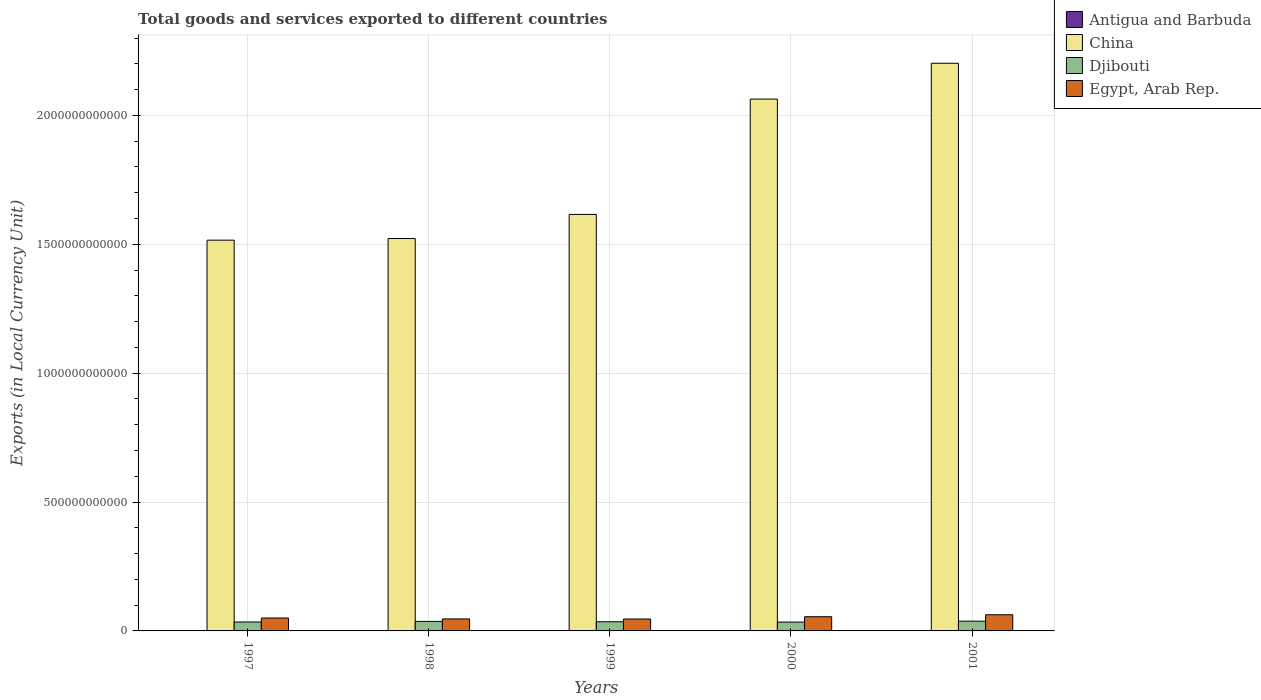Are the number of bars per tick equal to the number of legend labels?
Provide a short and direct response. Yes. How many bars are there on the 1st tick from the right?
Keep it short and to the point. 4. In how many cases, is the number of bars for a given year not equal to the number of legend labels?
Your answer should be compact. 0. What is the Amount of goods and services exports in China in 2000?
Ensure brevity in your answer.  2.06e+12. Across all years, what is the maximum Amount of goods and services exports in Egypt, Arab Rep.?
Give a very brief answer. 6.27e+1. Across all years, what is the minimum Amount of goods and services exports in China?
Make the answer very short. 1.52e+12. In which year was the Amount of goods and services exports in Djibouti maximum?
Provide a succinct answer. 2001. What is the total Amount of goods and services exports in Antigua and Barbuda in the graph?
Provide a short and direct response. 6.19e+09. What is the difference between the Amount of goods and services exports in Egypt, Arab Rep. in 1998 and that in 2001?
Make the answer very short. -1.61e+1. What is the difference between the Amount of goods and services exports in Antigua and Barbuda in 1998 and the Amount of goods and services exports in Djibouti in 1999?
Your response must be concise. -3.43e+1. What is the average Amount of goods and services exports in Egypt, Arab Rep. per year?
Offer a terse response. 5.22e+1. In the year 1997, what is the difference between the Amount of goods and services exports in China and Amount of goods and services exports in Antigua and Barbuda?
Provide a short and direct response. 1.51e+12. In how many years, is the Amount of goods and services exports in Djibouti greater than 1400000000000 LCU?
Make the answer very short. 0. What is the ratio of the Amount of goods and services exports in Antigua and Barbuda in 1998 to that in 2001?
Your answer should be very brief. 1.05. Is the Amount of goods and services exports in Djibouti in 1997 less than that in 2001?
Offer a very short reply. Yes. Is the difference between the Amount of goods and services exports in China in 1998 and 2000 greater than the difference between the Amount of goods and services exports in Antigua and Barbuda in 1998 and 2000?
Keep it short and to the point. No. What is the difference between the highest and the second highest Amount of goods and services exports in China?
Your response must be concise. 1.39e+11. What is the difference between the highest and the lowest Amount of goods and services exports in China?
Provide a succinct answer. 6.86e+11. What does the 2nd bar from the left in 2000 represents?
Keep it short and to the point. China. How many bars are there?
Your answer should be very brief. 20. Are all the bars in the graph horizontal?
Provide a short and direct response. No. What is the difference between two consecutive major ticks on the Y-axis?
Your response must be concise. 5.00e+11. Does the graph contain grids?
Provide a short and direct response. Yes. How many legend labels are there?
Ensure brevity in your answer.  4. How are the legend labels stacked?
Make the answer very short. Vertical. What is the title of the graph?
Keep it short and to the point. Total goods and services exported to different countries. What is the label or title of the X-axis?
Offer a very short reply. Years. What is the label or title of the Y-axis?
Offer a very short reply. Exports (in Local Currency Unit). What is the Exports (in Local Currency Unit) of Antigua and Barbuda in 1997?
Provide a short and direct response. 1.20e+09. What is the Exports (in Local Currency Unit) in China in 1997?
Provide a succinct answer. 1.52e+12. What is the Exports (in Local Currency Unit) of Djibouti in 1997?
Offer a very short reply. 3.47e+1. What is the Exports (in Local Currency Unit) in Egypt, Arab Rep. in 1997?
Your answer should be very brief. 5.01e+1. What is the Exports (in Local Currency Unit) of Antigua and Barbuda in 1998?
Provide a short and direct response. 1.26e+09. What is the Exports (in Local Currency Unit) of China in 1998?
Offer a terse response. 1.52e+12. What is the Exports (in Local Currency Unit) of Djibouti in 1998?
Ensure brevity in your answer.  3.70e+1. What is the Exports (in Local Currency Unit) in Egypt, Arab Rep. in 1998?
Provide a succinct answer. 4.66e+1. What is the Exports (in Local Currency Unit) in Antigua and Barbuda in 1999?
Provide a short and direct response. 1.28e+09. What is the Exports (in Local Currency Unit) of China in 1999?
Offer a terse response. 1.62e+12. What is the Exports (in Local Currency Unit) in Djibouti in 1999?
Keep it short and to the point. 3.56e+1. What is the Exports (in Local Currency Unit) of Egypt, Arab Rep. in 1999?
Offer a terse response. 4.63e+1. What is the Exports (in Local Currency Unit) of Antigua and Barbuda in 2000?
Ensure brevity in your answer.  1.26e+09. What is the Exports (in Local Currency Unit) in China in 2000?
Your answer should be compact. 2.06e+12. What is the Exports (in Local Currency Unit) in Djibouti in 2000?
Provide a succinct answer. 3.43e+1. What is the Exports (in Local Currency Unit) in Egypt, Arab Rep. in 2000?
Ensure brevity in your answer.  5.51e+1. What is the Exports (in Local Currency Unit) of Antigua and Barbuda in 2001?
Your answer should be compact. 1.20e+09. What is the Exports (in Local Currency Unit) of China in 2001?
Your response must be concise. 2.20e+12. What is the Exports (in Local Currency Unit) of Djibouti in 2001?
Offer a terse response. 3.79e+1. What is the Exports (in Local Currency Unit) of Egypt, Arab Rep. in 2001?
Provide a short and direct response. 6.27e+1. Across all years, what is the maximum Exports (in Local Currency Unit) of Antigua and Barbuda?
Offer a very short reply. 1.28e+09. Across all years, what is the maximum Exports (in Local Currency Unit) of China?
Your answer should be compact. 2.20e+12. Across all years, what is the maximum Exports (in Local Currency Unit) of Djibouti?
Your answer should be compact. 3.79e+1. Across all years, what is the maximum Exports (in Local Currency Unit) in Egypt, Arab Rep.?
Offer a terse response. 6.27e+1. Across all years, what is the minimum Exports (in Local Currency Unit) in Antigua and Barbuda?
Provide a succinct answer. 1.20e+09. Across all years, what is the minimum Exports (in Local Currency Unit) in China?
Your answer should be very brief. 1.52e+12. Across all years, what is the minimum Exports (in Local Currency Unit) of Djibouti?
Make the answer very short. 3.43e+1. Across all years, what is the minimum Exports (in Local Currency Unit) in Egypt, Arab Rep.?
Your answer should be very brief. 4.63e+1. What is the total Exports (in Local Currency Unit) of Antigua and Barbuda in the graph?
Give a very brief answer. 6.19e+09. What is the total Exports (in Local Currency Unit) in China in the graph?
Your response must be concise. 8.92e+12. What is the total Exports (in Local Currency Unit) in Djibouti in the graph?
Make the answer very short. 1.79e+11. What is the total Exports (in Local Currency Unit) in Egypt, Arab Rep. in the graph?
Your answer should be compact. 2.61e+11. What is the difference between the Exports (in Local Currency Unit) of Antigua and Barbuda in 1997 and that in 1998?
Ensure brevity in your answer.  -6.10e+07. What is the difference between the Exports (in Local Currency Unit) in China in 1997 and that in 1998?
Keep it short and to the point. -6.29e+09. What is the difference between the Exports (in Local Currency Unit) in Djibouti in 1997 and that in 1998?
Your answer should be compact. -2.28e+09. What is the difference between the Exports (in Local Currency Unit) of Egypt, Arab Rep. in 1997 and that in 1998?
Give a very brief answer. 3.50e+09. What is the difference between the Exports (in Local Currency Unit) in Antigua and Barbuda in 1997 and that in 1999?
Offer a terse response. -7.98e+07. What is the difference between the Exports (in Local Currency Unit) of China in 1997 and that in 1999?
Offer a very short reply. -9.99e+1. What is the difference between the Exports (in Local Currency Unit) in Djibouti in 1997 and that in 1999?
Ensure brevity in your answer.  -8.67e+08. What is the difference between the Exports (in Local Currency Unit) in Egypt, Arab Rep. in 1997 and that in 1999?
Keep it short and to the point. 3.80e+09. What is the difference between the Exports (in Local Currency Unit) of Antigua and Barbuda in 1997 and that in 2000?
Make the answer very short. -6.36e+07. What is the difference between the Exports (in Local Currency Unit) in China in 1997 and that in 2000?
Your answer should be very brief. -5.47e+11. What is the difference between the Exports (in Local Currency Unit) of Djibouti in 1997 and that in 2000?
Your answer should be very brief. 3.42e+08. What is the difference between the Exports (in Local Currency Unit) in Egypt, Arab Rep. in 1997 and that in 2000?
Offer a terse response. -5.00e+09. What is the difference between the Exports (in Local Currency Unit) in Antigua and Barbuda in 1997 and that in 2001?
Your answer should be very brief. -5.52e+06. What is the difference between the Exports (in Local Currency Unit) of China in 1997 and that in 2001?
Your answer should be very brief. -6.86e+11. What is the difference between the Exports (in Local Currency Unit) in Djibouti in 1997 and that in 2001?
Keep it short and to the point. -3.26e+09. What is the difference between the Exports (in Local Currency Unit) of Egypt, Arab Rep. in 1997 and that in 2001?
Your response must be concise. -1.26e+1. What is the difference between the Exports (in Local Currency Unit) of Antigua and Barbuda in 1998 and that in 1999?
Your answer should be compact. -1.87e+07. What is the difference between the Exports (in Local Currency Unit) in China in 1998 and that in 1999?
Your response must be concise. -9.36e+1. What is the difference between the Exports (in Local Currency Unit) of Djibouti in 1998 and that in 1999?
Ensure brevity in your answer.  1.41e+09. What is the difference between the Exports (in Local Currency Unit) in Egypt, Arab Rep. in 1998 and that in 1999?
Your response must be concise. 3.00e+08. What is the difference between the Exports (in Local Currency Unit) of Antigua and Barbuda in 1998 and that in 2000?
Offer a very short reply. -2.60e+06. What is the difference between the Exports (in Local Currency Unit) of China in 1998 and that in 2000?
Provide a succinct answer. -5.41e+11. What is the difference between the Exports (in Local Currency Unit) of Djibouti in 1998 and that in 2000?
Offer a very short reply. 2.62e+09. What is the difference between the Exports (in Local Currency Unit) of Egypt, Arab Rep. in 1998 and that in 2000?
Your response must be concise. -8.50e+09. What is the difference between the Exports (in Local Currency Unit) in Antigua and Barbuda in 1998 and that in 2001?
Provide a succinct answer. 5.55e+07. What is the difference between the Exports (in Local Currency Unit) in China in 1998 and that in 2001?
Your response must be concise. -6.80e+11. What is the difference between the Exports (in Local Currency Unit) in Djibouti in 1998 and that in 2001?
Ensure brevity in your answer.  -9.75e+08. What is the difference between the Exports (in Local Currency Unit) in Egypt, Arab Rep. in 1998 and that in 2001?
Your answer should be very brief. -1.61e+1. What is the difference between the Exports (in Local Currency Unit) of Antigua and Barbuda in 1999 and that in 2000?
Make the answer very short. 1.61e+07. What is the difference between the Exports (in Local Currency Unit) of China in 1999 and that in 2000?
Make the answer very short. -4.47e+11. What is the difference between the Exports (in Local Currency Unit) in Djibouti in 1999 and that in 2000?
Provide a succinct answer. 1.21e+09. What is the difference between the Exports (in Local Currency Unit) of Egypt, Arab Rep. in 1999 and that in 2000?
Your answer should be compact. -8.80e+09. What is the difference between the Exports (in Local Currency Unit) of Antigua and Barbuda in 1999 and that in 2001?
Keep it short and to the point. 7.42e+07. What is the difference between the Exports (in Local Currency Unit) in China in 1999 and that in 2001?
Offer a terse response. -5.86e+11. What is the difference between the Exports (in Local Currency Unit) in Djibouti in 1999 and that in 2001?
Offer a terse response. -2.39e+09. What is the difference between the Exports (in Local Currency Unit) of Egypt, Arab Rep. in 1999 and that in 2001?
Your answer should be very brief. -1.64e+1. What is the difference between the Exports (in Local Currency Unit) of Antigua and Barbuda in 2000 and that in 2001?
Provide a short and direct response. 5.81e+07. What is the difference between the Exports (in Local Currency Unit) in China in 2000 and that in 2001?
Offer a terse response. -1.39e+11. What is the difference between the Exports (in Local Currency Unit) in Djibouti in 2000 and that in 2001?
Offer a very short reply. -3.60e+09. What is the difference between the Exports (in Local Currency Unit) in Egypt, Arab Rep. in 2000 and that in 2001?
Your answer should be compact. -7.60e+09. What is the difference between the Exports (in Local Currency Unit) in Antigua and Barbuda in 1997 and the Exports (in Local Currency Unit) in China in 1998?
Provide a short and direct response. -1.52e+12. What is the difference between the Exports (in Local Currency Unit) in Antigua and Barbuda in 1997 and the Exports (in Local Currency Unit) in Djibouti in 1998?
Keep it short and to the point. -3.58e+1. What is the difference between the Exports (in Local Currency Unit) of Antigua and Barbuda in 1997 and the Exports (in Local Currency Unit) of Egypt, Arab Rep. in 1998?
Your answer should be very brief. -4.54e+1. What is the difference between the Exports (in Local Currency Unit) of China in 1997 and the Exports (in Local Currency Unit) of Djibouti in 1998?
Give a very brief answer. 1.48e+12. What is the difference between the Exports (in Local Currency Unit) in China in 1997 and the Exports (in Local Currency Unit) in Egypt, Arab Rep. in 1998?
Ensure brevity in your answer.  1.47e+12. What is the difference between the Exports (in Local Currency Unit) in Djibouti in 1997 and the Exports (in Local Currency Unit) in Egypt, Arab Rep. in 1998?
Provide a succinct answer. -1.19e+1. What is the difference between the Exports (in Local Currency Unit) in Antigua and Barbuda in 1997 and the Exports (in Local Currency Unit) in China in 1999?
Make the answer very short. -1.61e+12. What is the difference between the Exports (in Local Currency Unit) in Antigua and Barbuda in 1997 and the Exports (in Local Currency Unit) in Djibouti in 1999?
Ensure brevity in your answer.  -3.44e+1. What is the difference between the Exports (in Local Currency Unit) of Antigua and Barbuda in 1997 and the Exports (in Local Currency Unit) of Egypt, Arab Rep. in 1999?
Make the answer very short. -4.51e+1. What is the difference between the Exports (in Local Currency Unit) in China in 1997 and the Exports (in Local Currency Unit) in Djibouti in 1999?
Ensure brevity in your answer.  1.48e+12. What is the difference between the Exports (in Local Currency Unit) in China in 1997 and the Exports (in Local Currency Unit) in Egypt, Arab Rep. in 1999?
Your response must be concise. 1.47e+12. What is the difference between the Exports (in Local Currency Unit) of Djibouti in 1997 and the Exports (in Local Currency Unit) of Egypt, Arab Rep. in 1999?
Provide a succinct answer. -1.16e+1. What is the difference between the Exports (in Local Currency Unit) in Antigua and Barbuda in 1997 and the Exports (in Local Currency Unit) in China in 2000?
Your answer should be very brief. -2.06e+12. What is the difference between the Exports (in Local Currency Unit) in Antigua and Barbuda in 1997 and the Exports (in Local Currency Unit) in Djibouti in 2000?
Your answer should be compact. -3.31e+1. What is the difference between the Exports (in Local Currency Unit) of Antigua and Barbuda in 1997 and the Exports (in Local Currency Unit) of Egypt, Arab Rep. in 2000?
Make the answer very short. -5.39e+1. What is the difference between the Exports (in Local Currency Unit) in China in 1997 and the Exports (in Local Currency Unit) in Djibouti in 2000?
Offer a very short reply. 1.48e+12. What is the difference between the Exports (in Local Currency Unit) in China in 1997 and the Exports (in Local Currency Unit) in Egypt, Arab Rep. in 2000?
Keep it short and to the point. 1.46e+12. What is the difference between the Exports (in Local Currency Unit) of Djibouti in 1997 and the Exports (in Local Currency Unit) of Egypt, Arab Rep. in 2000?
Your response must be concise. -2.04e+1. What is the difference between the Exports (in Local Currency Unit) in Antigua and Barbuda in 1997 and the Exports (in Local Currency Unit) in China in 2001?
Ensure brevity in your answer.  -2.20e+12. What is the difference between the Exports (in Local Currency Unit) in Antigua and Barbuda in 1997 and the Exports (in Local Currency Unit) in Djibouti in 2001?
Provide a succinct answer. -3.67e+1. What is the difference between the Exports (in Local Currency Unit) in Antigua and Barbuda in 1997 and the Exports (in Local Currency Unit) in Egypt, Arab Rep. in 2001?
Your answer should be compact. -6.15e+1. What is the difference between the Exports (in Local Currency Unit) of China in 1997 and the Exports (in Local Currency Unit) of Djibouti in 2001?
Provide a succinct answer. 1.48e+12. What is the difference between the Exports (in Local Currency Unit) in China in 1997 and the Exports (in Local Currency Unit) in Egypt, Arab Rep. in 2001?
Give a very brief answer. 1.45e+12. What is the difference between the Exports (in Local Currency Unit) in Djibouti in 1997 and the Exports (in Local Currency Unit) in Egypt, Arab Rep. in 2001?
Give a very brief answer. -2.80e+1. What is the difference between the Exports (in Local Currency Unit) in Antigua and Barbuda in 1998 and the Exports (in Local Currency Unit) in China in 1999?
Offer a terse response. -1.61e+12. What is the difference between the Exports (in Local Currency Unit) in Antigua and Barbuda in 1998 and the Exports (in Local Currency Unit) in Djibouti in 1999?
Offer a terse response. -3.43e+1. What is the difference between the Exports (in Local Currency Unit) of Antigua and Barbuda in 1998 and the Exports (in Local Currency Unit) of Egypt, Arab Rep. in 1999?
Ensure brevity in your answer.  -4.50e+1. What is the difference between the Exports (in Local Currency Unit) in China in 1998 and the Exports (in Local Currency Unit) in Djibouti in 1999?
Keep it short and to the point. 1.49e+12. What is the difference between the Exports (in Local Currency Unit) in China in 1998 and the Exports (in Local Currency Unit) in Egypt, Arab Rep. in 1999?
Your response must be concise. 1.48e+12. What is the difference between the Exports (in Local Currency Unit) in Djibouti in 1998 and the Exports (in Local Currency Unit) in Egypt, Arab Rep. in 1999?
Your answer should be compact. -9.33e+09. What is the difference between the Exports (in Local Currency Unit) of Antigua and Barbuda in 1998 and the Exports (in Local Currency Unit) of China in 2000?
Provide a short and direct response. -2.06e+12. What is the difference between the Exports (in Local Currency Unit) of Antigua and Barbuda in 1998 and the Exports (in Local Currency Unit) of Djibouti in 2000?
Offer a terse response. -3.31e+1. What is the difference between the Exports (in Local Currency Unit) of Antigua and Barbuda in 1998 and the Exports (in Local Currency Unit) of Egypt, Arab Rep. in 2000?
Keep it short and to the point. -5.38e+1. What is the difference between the Exports (in Local Currency Unit) in China in 1998 and the Exports (in Local Currency Unit) in Djibouti in 2000?
Make the answer very short. 1.49e+12. What is the difference between the Exports (in Local Currency Unit) in China in 1998 and the Exports (in Local Currency Unit) in Egypt, Arab Rep. in 2000?
Your answer should be compact. 1.47e+12. What is the difference between the Exports (in Local Currency Unit) in Djibouti in 1998 and the Exports (in Local Currency Unit) in Egypt, Arab Rep. in 2000?
Give a very brief answer. -1.81e+1. What is the difference between the Exports (in Local Currency Unit) of Antigua and Barbuda in 1998 and the Exports (in Local Currency Unit) of China in 2001?
Offer a terse response. -2.20e+12. What is the difference between the Exports (in Local Currency Unit) of Antigua and Barbuda in 1998 and the Exports (in Local Currency Unit) of Djibouti in 2001?
Make the answer very short. -3.67e+1. What is the difference between the Exports (in Local Currency Unit) in Antigua and Barbuda in 1998 and the Exports (in Local Currency Unit) in Egypt, Arab Rep. in 2001?
Make the answer very short. -6.14e+1. What is the difference between the Exports (in Local Currency Unit) in China in 1998 and the Exports (in Local Currency Unit) in Djibouti in 2001?
Your response must be concise. 1.48e+12. What is the difference between the Exports (in Local Currency Unit) in China in 1998 and the Exports (in Local Currency Unit) in Egypt, Arab Rep. in 2001?
Keep it short and to the point. 1.46e+12. What is the difference between the Exports (in Local Currency Unit) of Djibouti in 1998 and the Exports (in Local Currency Unit) of Egypt, Arab Rep. in 2001?
Give a very brief answer. -2.57e+1. What is the difference between the Exports (in Local Currency Unit) in Antigua and Barbuda in 1999 and the Exports (in Local Currency Unit) in China in 2000?
Make the answer very short. -2.06e+12. What is the difference between the Exports (in Local Currency Unit) of Antigua and Barbuda in 1999 and the Exports (in Local Currency Unit) of Djibouti in 2000?
Your response must be concise. -3.31e+1. What is the difference between the Exports (in Local Currency Unit) in Antigua and Barbuda in 1999 and the Exports (in Local Currency Unit) in Egypt, Arab Rep. in 2000?
Keep it short and to the point. -5.38e+1. What is the difference between the Exports (in Local Currency Unit) in China in 1999 and the Exports (in Local Currency Unit) in Djibouti in 2000?
Make the answer very short. 1.58e+12. What is the difference between the Exports (in Local Currency Unit) in China in 1999 and the Exports (in Local Currency Unit) in Egypt, Arab Rep. in 2000?
Your answer should be very brief. 1.56e+12. What is the difference between the Exports (in Local Currency Unit) of Djibouti in 1999 and the Exports (in Local Currency Unit) of Egypt, Arab Rep. in 2000?
Ensure brevity in your answer.  -1.95e+1. What is the difference between the Exports (in Local Currency Unit) in Antigua and Barbuda in 1999 and the Exports (in Local Currency Unit) in China in 2001?
Offer a very short reply. -2.20e+12. What is the difference between the Exports (in Local Currency Unit) in Antigua and Barbuda in 1999 and the Exports (in Local Currency Unit) in Djibouti in 2001?
Provide a succinct answer. -3.67e+1. What is the difference between the Exports (in Local Currency Unit) in Antigua and Barbuda in 1999 and the Exports (in Local Currency Unit) in Egypt, Arab Rep. in 2001?
Give a very brief answer. -6.14e+1. What is the difference between the Exports (in Local Currency Unit) of China in 1999 and the Exports (in Local Currency Unit) of Djibouti in 2001?
Offer a terse response. 1.58e+12. What is the difference between the Exports (in Local Currency Unit) in China in 1999 and the Exports (in Local Currency Unit) in Egypt, Arab Rep. in 2001?
Give a very brief answer. 1.55e+12. What is the difference between the Exports (in Local Currency Unit) of Djibouti in 1999 and the Exports (in Local Currency Unit) of Egypt, Arab Rep. in 2001?
Keep it short and to the point. -2.71e+1. What is the difference between the Exports (in Local Currency Unit) in Antigua and Barbuda in 2000 and the Exports (in Local Currency Unit) in China in 2001?
Make the answer very short. -2.20e+12. What is the difference between the Exports (in Local Currency Unit) of Antigua and Barbuda in 2000 and the Exports (in Local Currency Unit) of Djibouti in 2001?
Offer a terse response. -3.67e+1. What is the difference between the Exports (in Local Currency Unit) of Antigua and Barbuda in 2000 and the Exports (in Local Currency Unit) of Egypt, Arab Rep. in 2001?
Ensure brevity in your answer.  -6.14e+1. What is the difference between the Exports (in Local Currency Unit) of China in 2000 and the Exports (in Local Currency Unit) of Djibouti in 2001?
Give a very brief answer. 2.03e+12. What is the difference between the Exports (in Local Currency Unit) of China in 2000 and the Exports (in Local Currency Unit) of Egypt, Arab Rep. in 2001?
Provide a succinct answer. 2.00e+12. What is the difference between the Exports (in Local Currency Unit) of Djibouti in 2000 and the Exports (in Local Currency Unit) of Egypt, Arab Rep. in 2001?
Your answer should be very brief. -2.84e+1. What is the average Exports (in Local Currency Unit) in Antigua and Barbuda per year?
Your answer should be very brief. 1.24e+09. What is the average Exports (in Local Currency Unit) of China per year?
Offer a terse response. 1.78e+12. What is the average Exports (in Local Currency Unit) of Djibouti per year?
Your answer should be compact. 3.59e+1. What is the average Exports (in Local Currency Unit) in Egypt, Arab Rep. per year?
Ensure brevity in your answer.  5.22e+1. In the year 1997, what is the difference between the Exports (in Local Currency Unit) of Antigua and Barbuda and Exports (in Local Currency Unit) of China?
Ensure brevity in your answer.  -1.51e+12. In the year 1997, what is the difference between the Exports (in Local Currency Unit) in Antigua and Barbuda and Exports (in Local Currency Unit) in Djibouti?
Provide a short and direct response. -3.35e+1. In the year 1997, what is the difference between the Exports (in Local Currency Unit) of Antigua and Barbuda and Exports (in Local Currency Unit) of Egypt, Arab Rep.?
Offer a very short reply. -4.89e+1. In the year 1997, what is the difference between the Exports (in Local Currency Unit) in China and Exports (in Local Currency Unit) in Djibouti?
Offer a very short reply. 1.48e+12. In the year 1997, what is the difference between the Exports (in Local Currency Unit) in China and Exports (in Local Currency Unit) in Egypt, Arab Rep.?
Provide a succinct answer. 1.47e+12. In the year 1997, what is the difference between the Exports (in Local Currency Unit) of Djibouti and Exports (in Local Currency Unit) of Egypt, Arab Rep.?
Ensure brevity in your answer.  -1.54e+1. In the year 1998, what is the difference between the Exports (in Local Currency Unit) of Antigua and Barbuda and Exports (in Local Currency Unit) of China?
Your response must be concise. -1.52e+12. In the year 1998, what is the difference between the Exports (in Local Currency Unit) in Antigua and Barbuda and Exports (in Local Currency Unit) in Djibouti?
Give a very brief answer. -3.57e+1. In the year 1998, what is the difference between the Exports (in Local Currency Unit) of Antigua and Barbuda and Exports (in Local Currency Unit) of Egypt, Arab Rep.?
Ensure brevity in your answer.  -4.53e+1. In the year 1998, what is the difference between the Exports (in Local Currency Unit) in China and Exports (in Local Currency Unit) in Djibouti?
Provide a short and direct response. 1.49e+12. In the year 1998, what is the difference between the Exports (in Local Currency Unit) of China and Exports (in Local Currency Unit) of Egypt, Arab Rep.?
Your response must be concise. 1.48e+12. In the year 1998, what is the difference between the Exports (in Local Currency Unit) of Djibouti and Exports (in Local Currency Unit) of Egypt, Arab Rep.?
Provide a short and direct response. -9.63e+09. In the year 1999, what is the difference between the Exports (in Local Currency Unit) in Antigua and Barbuda and Exports (in Local Currency Unit) in China?
Offer a very short reply. -1.61e+12. In the year 1999, what is the difference between the Exports (in Local Currency Unit) in Antigua and Barbuda and Exports (in Local Currency Unit) in Djibouti?
Your answer should be compact. -3.43e+1. In the year 1999, what is the difference between the Exports (in Local Currency Unit) in Antigua and Barbuda and Exports (in Local Currency Unit) in Egypt, Arab Rep.?
Your answer should be compact. -4.50e+1. In the year 1999, what is the difference between the Exports (in Local Currency Unit) of China and Exports (in Local Currency Unit) of Djibouti?
Offer a terse response. 1.58e+12. In the year 1999, what is the difference between the Exports (in Local Currency Unit) of China and Exports (in Local Currency Unit) of Egypt, Arab Rep.?
Keep it short and to the point. 1.57e+12. In the year 1999, what is the difference between the Exports (in Local Currency Unit) in Djibouti and Exports (in Local Currency Unit) in Egypt, Arab Rep.?
Give a very brief answer. -1.07e+1. In the year 2000, what is the difference between the Exports (in Local Currency Unit) in Antigua and Barbuda and Exports (in Local Currency Unit) in China?
Provide a short and direct response. -2.06e+12. In the year 2000, what is the difference between the Exports (in Local Currency Unit) of Antigua and Barbuda and Exports (in Local Currency Unit) of Djibouti?
Offer a very short reply. -3.31e+1. In the year 2000, what is the difference between the Exports (in Local Currency Unit) of Antigua and Barbuda and Exports (in Local Currency Unit) of Egypt, Arab Rep.?
Ensure brevity in your answer.  -5.38e+1. In the year 2000, what is the difference between the Exports (in Local Currency Unit) in China and Exports (in Local Currency Unit) in Djibouti?
Make the answer very short. 2.03e+12. In the year 2000, what is the difference between the Exports (in Local Currency Unit) of China and Exports (in Local Currency Unit) of Egypt, Arab Rep.?
Your response must be concise. 2.01e+12. In the year 2000, what is the difference between the Exports (in Local Currency Unit) in Djibouti and Exports (in Local Currency Unit) in Egypt, Arab Rep.?
Your response must be concise. -2.08e+1. In the year 2001, what is the difference between the Exports (in Local Currency Unit) in Antigua and Barbuda and Exports (in Local Currency Unit) in China?
Offer a terse response. -2.20e+12. In the year 2001, what is the difference between the Exports (in Local Currency Unit) in Antigua and Barbuda and Exports (in Local Currency Unit) in Djibouti?
Give a very brief answer. -3.67e+1. In the year 2001, what is the difference between the Exports (in Local Currency Unit) in Antigua and Barbuda and Exports (in Local Currency Unit) in Egypt, Arab Rep.?
Provide a short and direct response. -6.15e+1. In the year 2001, what is the difference between the Exports (in Local Currency Unit) in China and Exports (in Local Currency Unit) in Djibouti?
Ensure brevity in your answer.  2.16e+12. In the year 2001, what is the difference between the Exports (in Local Currency Unit) in China and Exports (in Local Currency Unit) in Egypt, Arab Rep.?
Give a very brief answer. 2.14e+12. In the year 2001, what is the difference between the Exports (in Local Currency Unit) of Djibouti and Exports (in Local Currency Unit) of Egypt, Arab Rep.?
Offer a very short reply. -2.48e+1. What is the ratio of the Exports (in Local Currency Unit) of Antigua and Barbuda in 1997 to that in 1998?
Provide a succinct answer. 0.95. What is the ratio of the Exports (in Local Currency Unit) in China in 1997 to that in 1998?
Provide a short and direct response. 1. What is the ratio of the Exports (in Local Currency Unit) of Djibouti in 1997 to that in 1998?
Your answer should be compact. 0.94. What is the ratio of the Exports (in Local Currency Unit) of Egypt, Arab Rep. in 1997 to that in 1998?
Your answer should be compact. 1.08. What is the ratio of the Exports (in Local Currency Unit) in Antigua and Barbuda in 1997 to that in 1999?
Make the answer very short. 0.94. What is the ratio of the Exports (in Local Currency Unit) of China in 1997 to that in 1999?
Provide a succinct answer. 0.94. What is the ratio of the Exports (in Local Currency Unit) in Djibouti in 1997 to that in 1999?
Your answer should be very brief. 0.98. What is the ratio of the Exports (in Local Currency Unit) in Egypt, Arab Rep. in 1997 to that in 1999?
Give a very brief answer. 1.08. What is the ratio of the Exports (in Local Currency Unit) of Antigua and Barbuda in 1997 to that in 2000?
Make the answer very short. 0.95. What is the ratio of the Exports (in Local Currency Unit) in China in 1997 to that in 2000?
Your answer should be very brief. 0.73. What is the ratio of the Exports (in Local Currency Unit) in Djibouti in 1997 to that in 2000?
Provide a short and direct response. 1.01. What is the ratio of the Exports (in Local Currency Unit) of Egypt, Arab Rep. in 1997 to that in 2000?
Provide a short and direct response. 0.91. What is the ratio of the Exports (in Local Currency Unit) in China in 1997 to that in 2001?
Offer a very short reply. 0.69. What is the ratio of the Exports (in Local Currency Unit) in Djibouti in 1997 to that in 2001?
Provide a short and direct response. 0.91. What is the ratio of the Exports (in Local Currency Unit) in Egypt, Arab Rep. in 1997 to that in 2001?
Provide a succinct answer. 0.8. What is the ratio of the Exports (in Local Currency Unit) in Antigua and Barbuda in 1998 to that in 1999?
Keep it short and to the point. 0.99. What is the ratio of the Exports (in Local Currency Unit) of China in 1998 to that in 1999?
Provide a succinct answer. 0.94. What is the ratio of the Exports (in Local Currency Unit) in Djibouti in 1998 to that in 1999?
Your answer should be compact. 1.04. What is the ratio of the Exports (in Local Currency Unit) of China in 1998 to that in 2000?
Your response must be concise. 0.74. What is the ratio of the Exports (in Local Currency Unit) of Djibouti in 1998 to that in 2000?
Offer a very short reply. 1.08. What is the ratio of the Exports (in Local Currency Unit) of Egypt, Arab Rep. in 1998 to that in 2000?
Offer a very short reply. 0.85. What is the ratio of the Exports (in Local Currency Unit) in Antigua and Barbuda in 1998 to that in 2001?
Keep it short and to the point. 1.05. What is the ratio of the Exports (in Local Currency Unit) in China in 1998 to that in 2001?
Ensure brevity in your answer.  0.69. What is the ratio of the Exports (in Local Currency Unit) in Djibouti in 1998 to that in 2001?
Offer a very short reply. 0.97. What is the ratio of the Exports (in Local Currency Unit) in Egypt, Arab Rep. in 1998 to that in 2001?
Offer a very short reply. 0.74. What is the ratio of the Exports (in Local Currency Unit) of Antigua and Barbuda in 1999 to that in 2000?
Make the answer very short. 1.01. What is the ratio of the Exports (in Local Currency Unit) of China in 1999 to that in 2000?
Your response must be concise. 0.78. What is the ratio of the Exports (in Local Currency Unit) of Djibouti in 1999 to that in 2000?
Your answer should be compact. 1.04. What is the ratio of the Exports (in Local Currency Unit) of Egypt, Arab Rep. in 1999 to that in 2000?
Your response must be concise. 0.84. What is the ratio of the Exports (in Local Currency Unit) in Antigua and Barbuda in 1999 to that in 2001?
Offer a terse response. 1.06. What is the ratio of the Exports (in Local Currency Unit) in China in 1999 to that in 2001?
Offer a terse response. 0.73. What is the ratio of the Exports (in Local Currency Unit) of Djibouti in 1999 to that in 2001?
Your answer should be compact. 0.94. What is the ratio of the Exports (in Local Currency Unit) of Egypt, Arab Rep. in 1999 to that in 2001?
Provide a short and direct response. 0.74. What is the ratio of the Exports (in Local Currency Unit) of Antigua and Barbuda in 2000 to that in 2001?
Ensure brevity in your answer.  1.05. What is the ratio of the Exports (in Local Currency Unit) of China in 2000 to that in 2001?
Your answer should be very brief. 0.94. What is the ratio of the Exports (in Local Currency Unit) in Djibouti in 2000 to that in 2001?
Offer a very short reply. 0.91. What is the ratio of the Exports (in Local Currency Unit) of Egypt, Arab Rep. in 2000 to that in 2001?
Your answer should be compact. 0.88. What is the difference between the highest and the second highest Exports (in Local Currency Unit) of Antigua and Barbuda?
Your answer should be very brief. 1.61e+07. What is the difference between the highest and the second highest Exports (in Local Currency Unit) in China?
Provide a short and direct response. 1.39e+11. What is the difference between the highest and the second highest Exports (in Local Currency Unit) in Djibouti?
Keep it short and to the point. 9.75e+08. What is the difference between the highest and the second highest Exports (in Local Currency Unit) of Egypt, Arab Rep.?
Your answer should be very brief. 7.60e+09. What is the difference between the highest and the lowest Exports (in Local Currency Unit) in Antigua and Barbuda?
Keep it short and to the point. 7.98e+07. What is the difference between the highest and the lowest Exports (in Local Currency Unit) of China?
Provide a succinct answer. 6.86e+11. What is the difference between the highest and the lowest Exports (in Local Currency Unit) of Djibouti?
Your response must be concise. 3.60e+09. What is the difference between the highest and the lowest Exports (in Local Currency Unit) of Egypt, Arab Rep.?
Ensure brevity in your answer.  1.64e+1. 